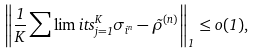<formula> <loc_0><loc_0><loc_500><loc_500>\left \| \frac { 1 } { K } \sum \lim i t s _ { j = 1 } ^ { K } \sigma _ { i ^ { n } } - \tilde { \rho } ^ { ( n ) } \right \| _ { 1 } \leq o ( 1 ) ,</formula> 